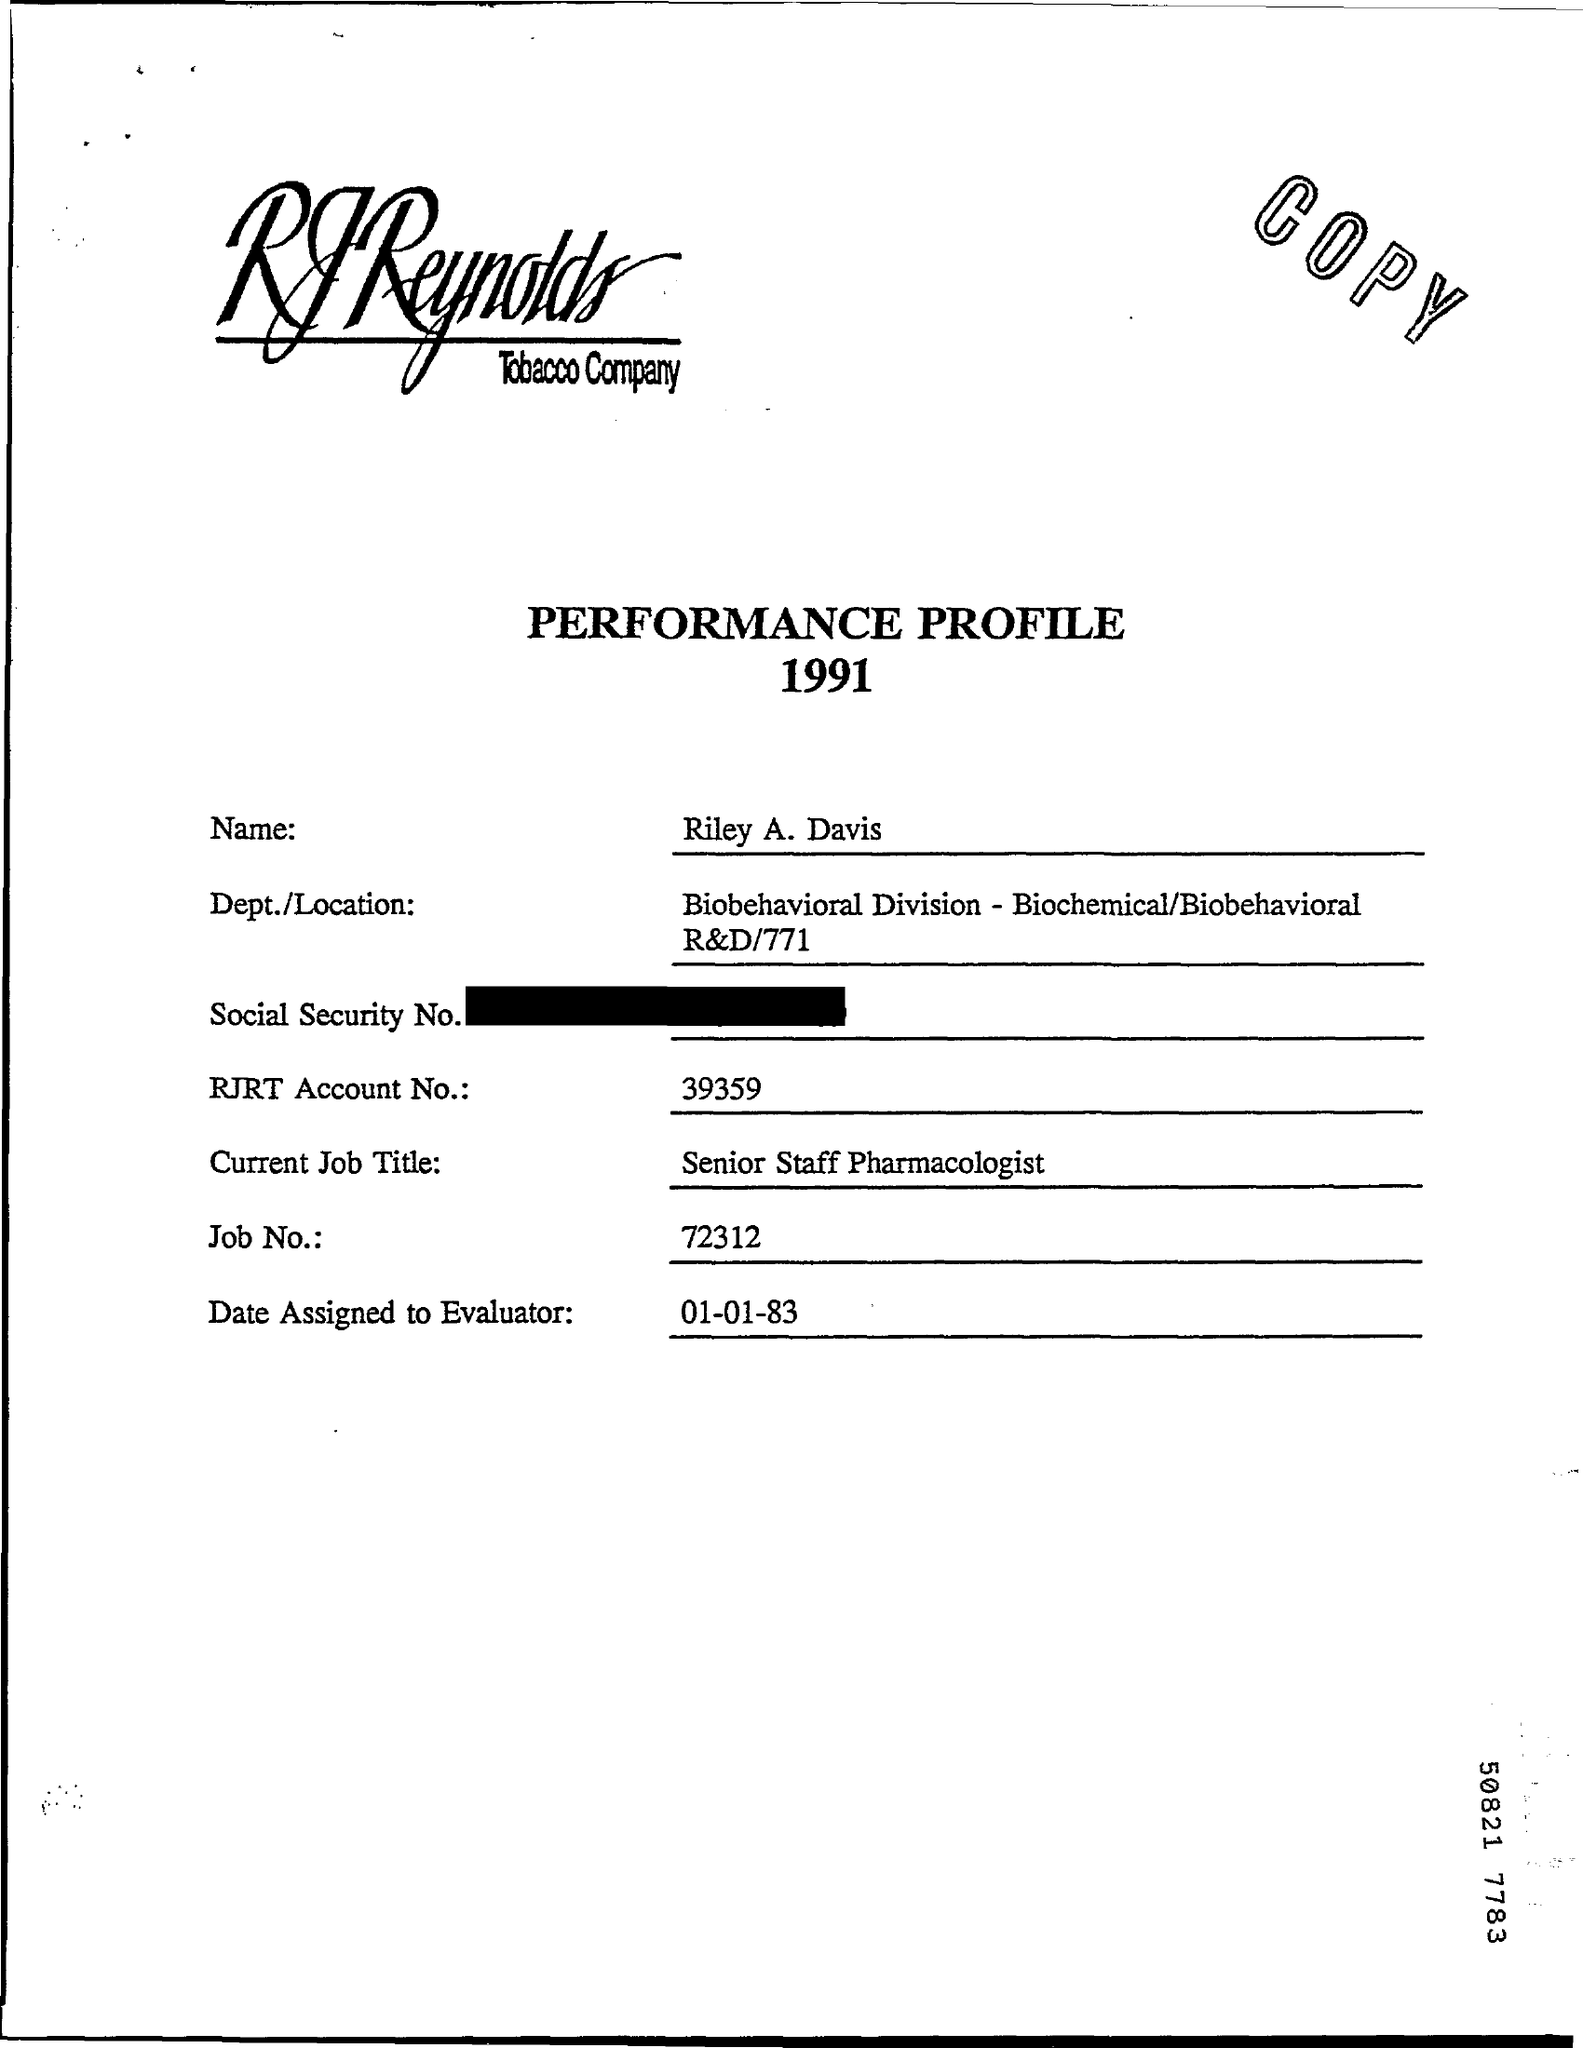Highlight a few significant elements in this photo. The job number is 72312... The RJRT Account No. is 39359. Riley a. davis is the name. On what date was the evaluator assigned? The performance profile for 1991 is titled "What is the Title of the document?". 